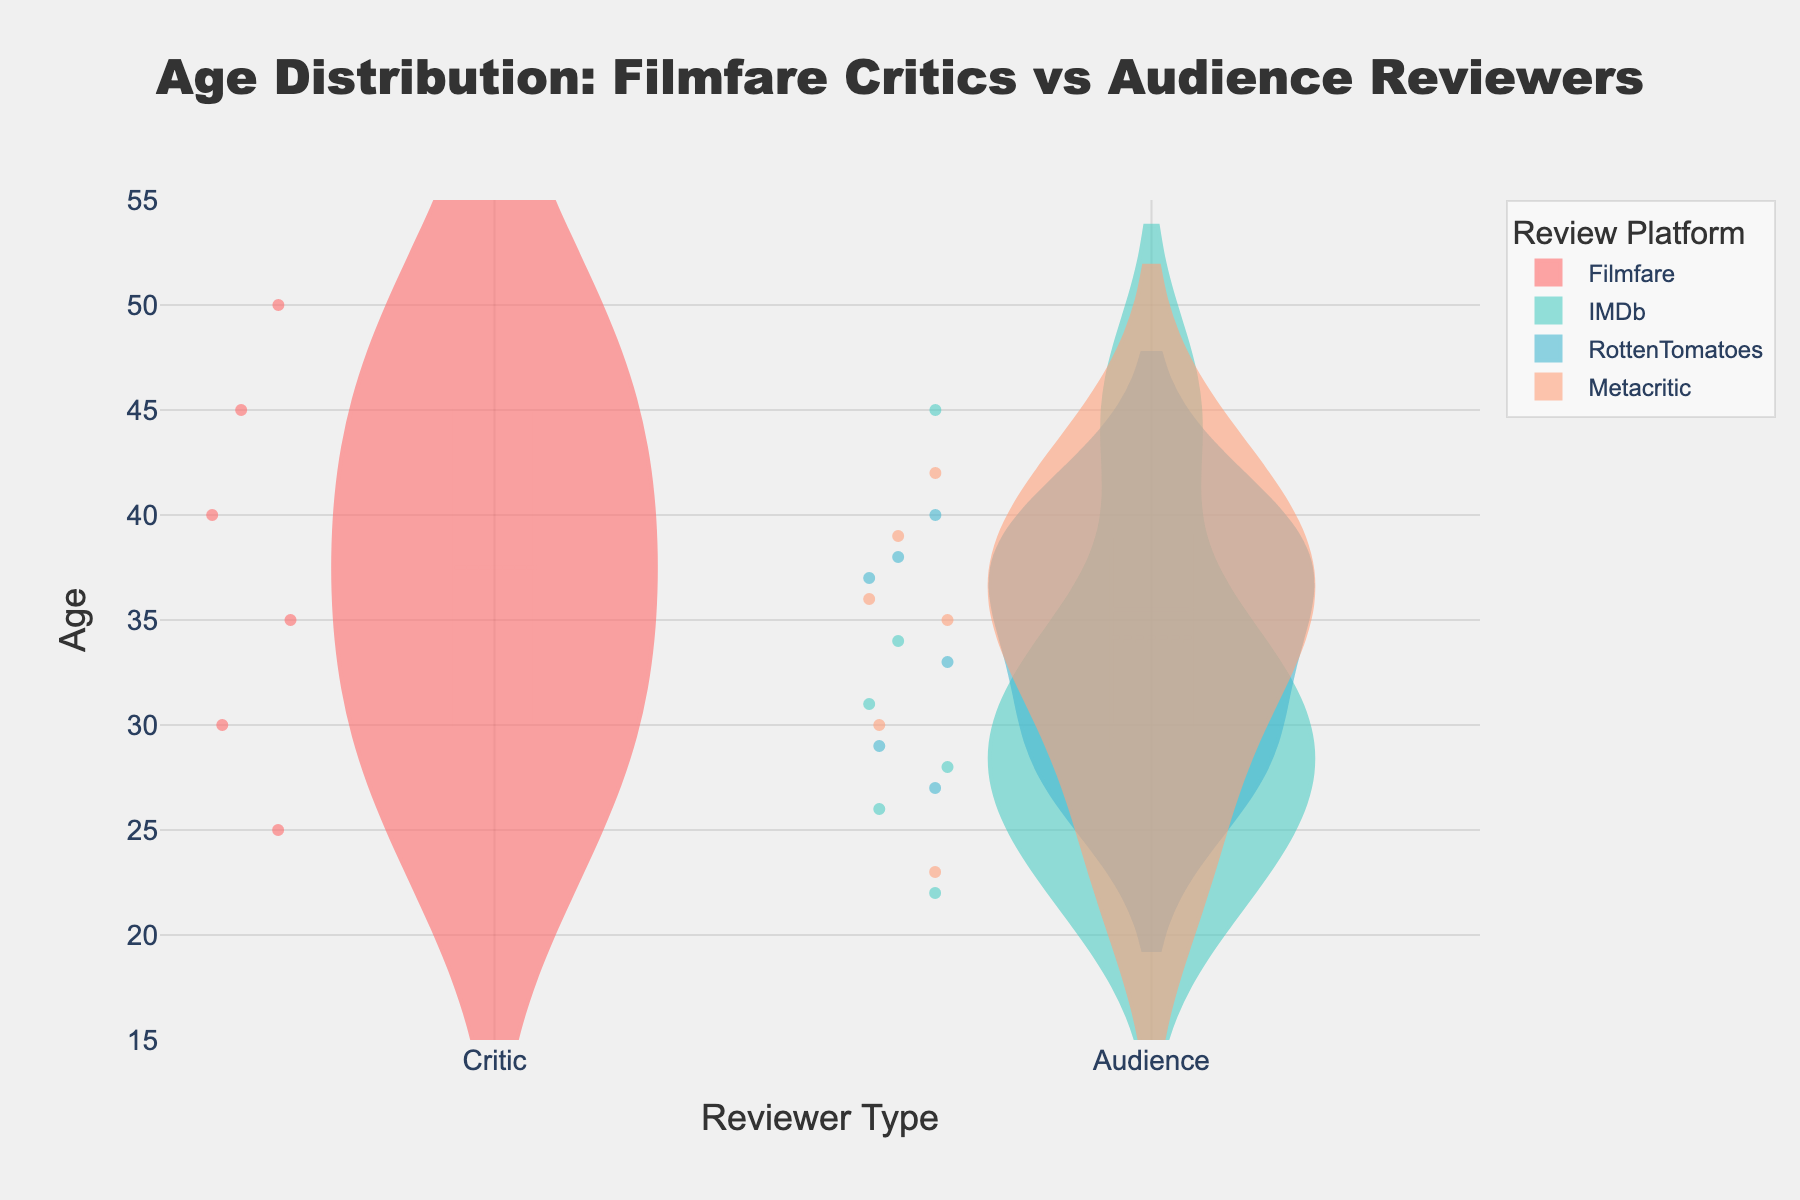What is the title of the figure? The title of the figure is written at the top and it states "Age Distribution: Filmfare Critics vs Audience Reviewers".
Answer: Age Distribution: Filmfare Critics vs Audience Reviewers Which reviewer type has the highest median age according to the figure? The median age is indicated by the line within each violin plot. By examining the plots, the Filmfare Critics have the highest median age compared to the audience reviewers.
Answer: Filmfare Critics What is the age range of Filmfare critics visible in the figure? Observing the violin plot for Filmfare critics, the ages range from 25 to 50.
Answer: 25 to 50 Which platform's audience reviewers have the most varied age distribution? By looking at the spread of the age values within each violin plot, Rotten Tomatoes audience reviewers have the most varied age distribution.
Answer: Rotten Tomatoes Between IMDb and Metacritic audience reviewers, whose age distribution is more concentrated around the median? IMDb audience reviewers have a more concentrated distribution around the median as indicated by the narrow spread in the violin plot compared to Metacritic.
Answer: IMDb What is the mean age of Rotten Tomatoes audience reviewers? The mean age is indicated by the horizontal line within the violin plot for Rotten Tomatoes audience reviewers. By verifying the mean line position, you can see it is around 33-34.
Answer: Around 33-34 How does the age distribution of IMDb audience reviewers compare to Metacritic audience reviewers? The violin plot shows that IMDb audience reviewers have a narrower distribution, indicating less variance in age, while Metacritic audience reviewers have a wider distribution, indicating more variance in age.
Answer: IMDb has less age variance What is the primary color representing Filmfare critics in the figure? Each entity is represented by a unique color within the violin plot traces. Filmfare critics are marked with a distinct red color.
Answer: Red Which audience review platform has the oldest reviewer, and what is their age? By looking at the highest point in each violin plot for audience reviewers, Rotten Tomatoes has the oldest reviewer at age 42.
Answer: Rotten Tomatoes, 42 